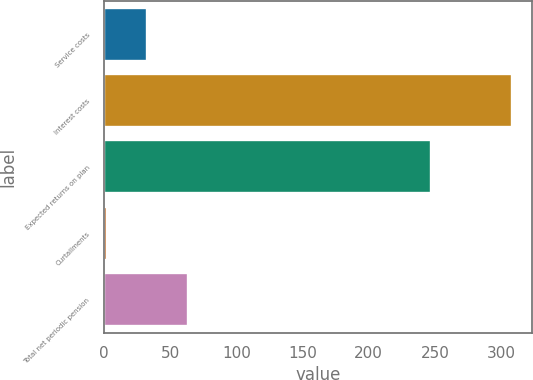<chart> <loc_0><loc_0><loc_500><loc_500><bar_chart><fcel>Service costs<fcel>Interest costs<fcel>Expected returns on plan<fcel>Curtailments<fcel>Total net periodic pension<nl><fcel>32.6<fcel>308<fcel>247<fcel>2<fcel>63.2<nl></chart> 